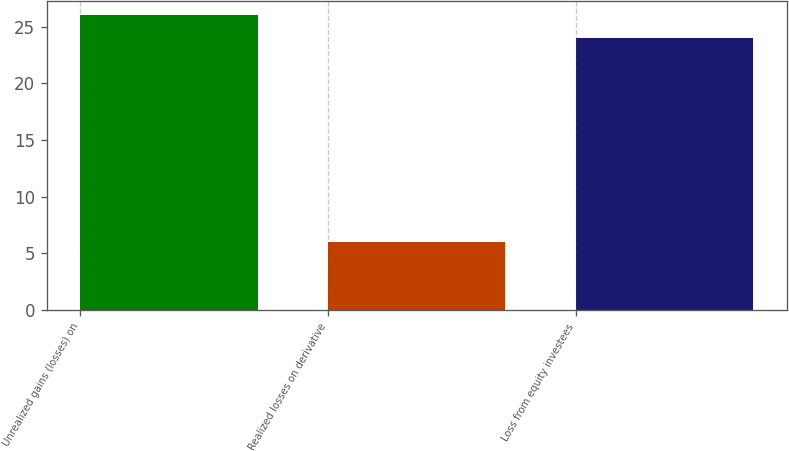Convert chart. <chart><loc_0><loc_0><loc_500><loc_500><bar_chart><fcel>Unrealized gains (losses) on<fcel>Realized losses on derivative<fcel>Loss from equity investees<nl><fcel>26<fcel>6<fcel>24<nl></chart> 